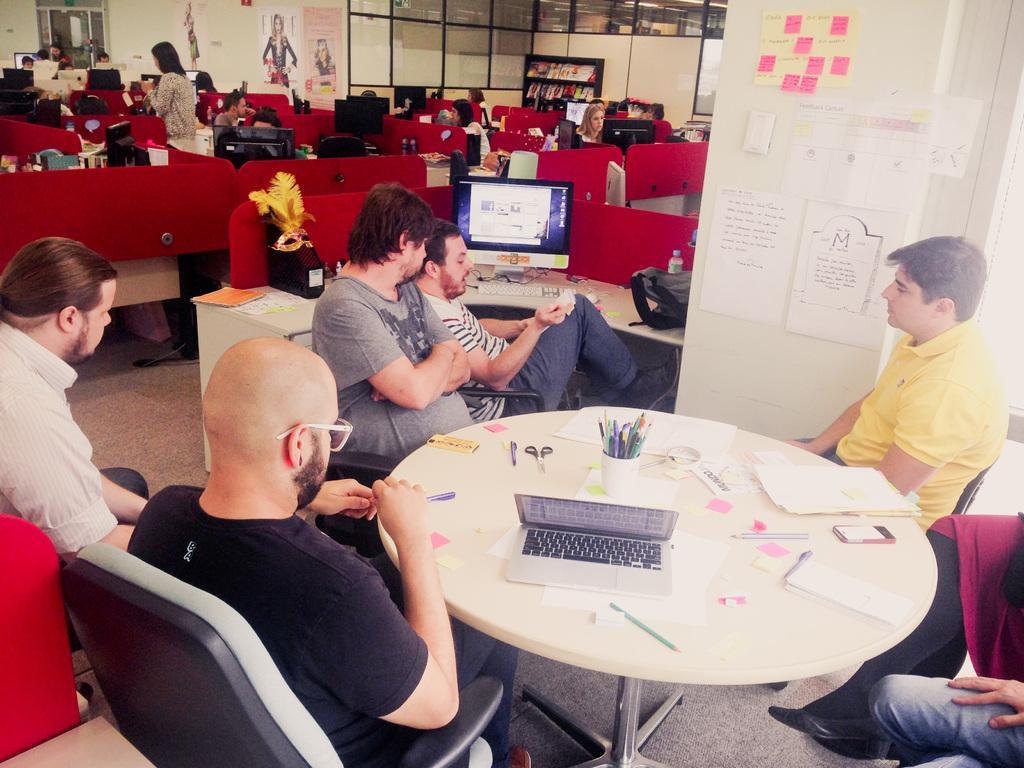Describe this image in one or two sentences. In this image i can see a number of people sitting on chairs around a table. on the table i can see a laptop, few pens and few papers. In the background i can see number of people sitting in front of monitors, few posters and a wall. 